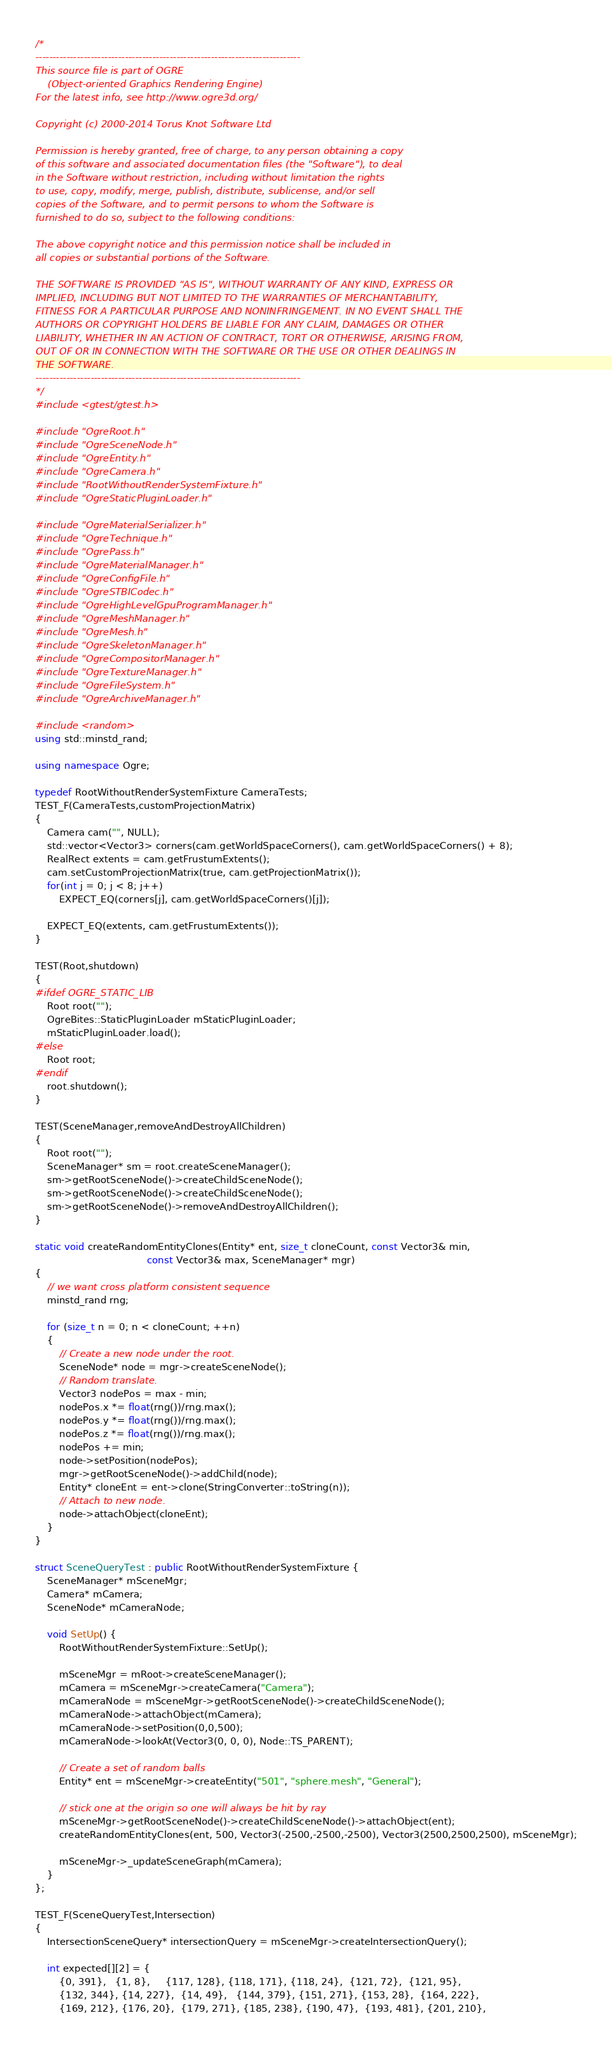<code> <loc_0><loc_0><loc_500><loc_500><_C++_>/*
-----------------------------------------------------------------------------
This source file is part of OGRE
    (Object-oriented Graphics Rendering Engine)
For the latest info, see http://www.ogre3d.org/

Copyright (c) 2000-2014 Torus Knot Software Ltd

Permission is hereby granted, free of charge, to any person obtaining a copy
of this software and associated documentation files (the "Software"), to deal
in the Software without restriction, including without limitation the rights
to use, copy, modify, merge, publish, distribute, sublicense, and/or sell
copies of the Software, and to permit persons to whom the Software is
furnished to do so, subject to the following conditions:

The above copyright notice and this permission notice shall be included in
all copies or substantial portions of the Software.

THE SOFTWARE IS PROVIDED "AS IS", WITHOUT WARRANTY OF ANY KIND, EXPRESS OR
IMPLIED, INCLUDING BUT NOT LIMITED TO THE WARRANTIES OF MERCHANTABILITY,
FITNESS FOR A PARTICULAR PURPOSE AND NONINFRINGEMENT. IN NO EVENT SHALL THE
AUTHORS OR COPYRIGHT HOLDERS BE LIABLE FOR ANY CLAIM, DAMAGES OR OTHER
LIABILITY, WHETHER IN AN ACTION OF CONTRACT, TORT OR OTHERWISE, ARISING FROM,
OUT OF OR IN CONNECTION WITH THE SOFTWARE OR THE USE OR OTHER DEALINGS IN
THE SOFTWARE.
-----------------------------------------------------------------------------
*/
#include <gtest/gtest.h>

#include "OgreRoot.h"
#include "OgreSceneNode.h"
#include "OgreEntity.h"
#include "OgreCamera.h"
#include "RootWithoutRenderSystemFixture.h"
#include "OgreStaticPluginLoader.h"

#include "OgreMaterialSerializer.h"
#include "OgreTechnique.h"
#include "OgrePass.h"
#include "OgreMaterialManager.h"
#include "OgreConfigFile.h"
#include "OgreSTBICodec.h"
#include "OgreHighLevelGpuProgramManager.h"
#include "OgreMeshManager.h"
#include "OgreMesh.h"
#include "OgreSkeletonManager.h"
#include "OgreCompositorManager.h"
#include "OgreTextureManager.h"
#include "OgreFileSystem.h"
#include "OgreArchiveManager.h"

#include <random>
using std::minstd_rand;

using namespace Ogre;

typedef RootWithoutRenderSystemFixture CameraTests;
TEST_F(CameraTests,customProjectionMatrix)
{
    Camera cam("", NULL);
    std::vector<Vector3> corners(cam.getWorldSpaceCorners(), cam.getWorldSpaceCorners() + 8);
    RealRect extents = cam.getFrustumExtents();
    cam.setCustomProjectionMatrix(true, cam.getProjectionMatrix());
    for(int j = 0; j < 8; j++)
        EXPECT_EQ(corners[j], cam.getWorldSpaceCorners()[j]);

    EXPECT_EQ(extents, cam.getFrustumExtents());
}

TEST(Root,shutdown)
{
#ifdef OGRE_STATIC_LIB
    Root root("");
    OgreBites::StaticPluginLoader mStaticPluginLoader;
    mStaticPluginLoader.load();
#else
    Root root;
#endif
    root.shutdown();
}

TEST(SceneManager,removeAndDestroyAllChildren)
{
    Root root("");
    SceneManager* sm = root.createSceneManager();
    sm->getRootSceneNode()->createChildSceneNode();
    sm->getRootSceneNode()->createChildSceneNode();
    sm->getRootSceneNode()->removeAndDestroyAllChildren();
}

static void createRandomEntityClones(Entity* ent, size_t cloneCount, const Vector3& min,
                                     const Vector3& max, SceneManager* mgr)
{
    // we want cross platform consistent sequence
    minstd_rand rng;

    for (size_t n = 0; n < cloneCount; ++n)
    {
        // Create a new node under the root.
        SceneNode* node = mgr->createSceneNode();
        // Random translate.
        Vector3 nodePos = max - min;
        nodePos.x *= float(rng())/rng.max();
        nodePos.y *= float(rng())/rng.max();
        nodePos.z *= float(rng())/rng.max();
        nodePos += min;
        node->setPosition(nodePos);
        mgr->getRootSceneNode()->addChild(node);
        Entity* cloneEnt = ent->clone(StringConverter::toString(n));
        // Attach to new node.
        node->attachObject(cloneEnt);
    }
}

struct SceneQueryTest : public RootWithoutRenderSystemFixture {
    SceneManager* mSceneMgr;
    Camera* mCamera;
    SceneNode* mCameraNode;

    void SetUp() {
        RootWithoutRenderSystemFixture::SetUp();

        mSceneMgr = mRoot->createSceneManager();
        mCamera = mSceneMgr->createCamera("Camera");
        mCameraNode = mSceneMgr->getRootSceneNode()->createChildSceneNode();
        mCameraNode->attachObject(mCamera);
        mCameraNode->setPosition(0,0,500);
        mCameraNode->lookAt(Vector3(0, 0, 0), Node::TS_PARENT);

        // Create a set of random balls
        Entity* ent = mSceneMgr->createEntity("501", "sphere.mesh", "General");

        // stick one at the origin so one will always be hit by ray
        mSceneMgr->getRootSceneNode()->createChildSceneNode()->attachObject(ent);
        createRandomEntityClones(ent, 500, Vector3(-2500,-2500,-2500), Vector3(2500,2500,2500), mSceneMgr);

        mSceneMgr->_updateSceneGraph(mCamera);
    }
};

TEST_F(SceneQueryTest,Intersection)
{
    IntersectionSceneQuery* intersectionQuery = mSceneMgr->createIntersectionQuery();

    int expected[][2] = {
        {0, 391},   {1, 8},     {117, 128}, {118, 171}, {118, 24},  {121, 72},  {121, 95},
        {132, 344}, {14, 227},  {14, 49},   {144, 379}, {151, 271}, {153, 28},  {164, 222},
        {169, 212}, {176, 20},  {179, 271}, {185, 238}, {190, 47},  {193, 481}, {201, 210},</code> 